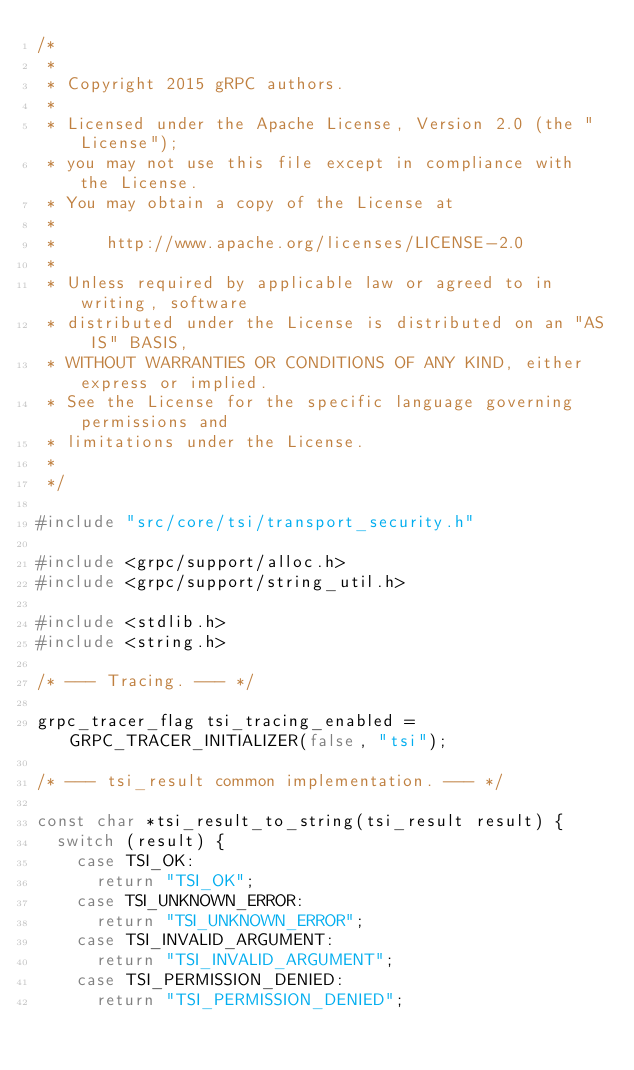<code> <loc_0><loc_0><loc_500><loc_500><_C++_>/*
 *
 * Copyright 2015 gRPC authors.
 *
 * Licensed under the Apache License, Version 2.0 (the "License");
 * you may not use this file except in compliance with the License.
 * You may obtain a copy of the License at
 *
 *     http://www.apache.org/licenses/LICENSE-2.0
 *
 * Unless required by applicable law or agreed to in writing, software
 * distributed under the License is distributed on an "AS IS" BASIS,
 * WITHOUT WARRANTIES OR CONDITIONS OF ANY KIND, either express or implied.
 * See the License for the specific language governing permissions and
 * limitations under the License.
 *
 */

#include "src/core/tsi/transport_security.h"

#include <grpc/support/alloc.h>
#include <grpc/support/string_util.h>

#include <stdlib.h>
#include <string.h>

/* --- Tracing. --- */

grpc_tracer_flag tsi_tracing_enabled = GRPC_TRACER_INITIALIZER(false, "tsi");

/* --- tsi_result common implementation. --- */

const char *tsi_result_to_string(tsi_result result) {
  switch (result) {
    case TSI_OK:
      return "TSI_OK";
    case TSI_UNKNOWN_ERROR:
      return "TSI_UNKNOWN_ERROR";
    case TSI_INVALID_ARGUMENT:
      return "TSI_INVALID_ARGUMENT";
    case TSI_PERMISSION_DENIED:
      return "TSI_PERMISSION_DENIED";</code> 